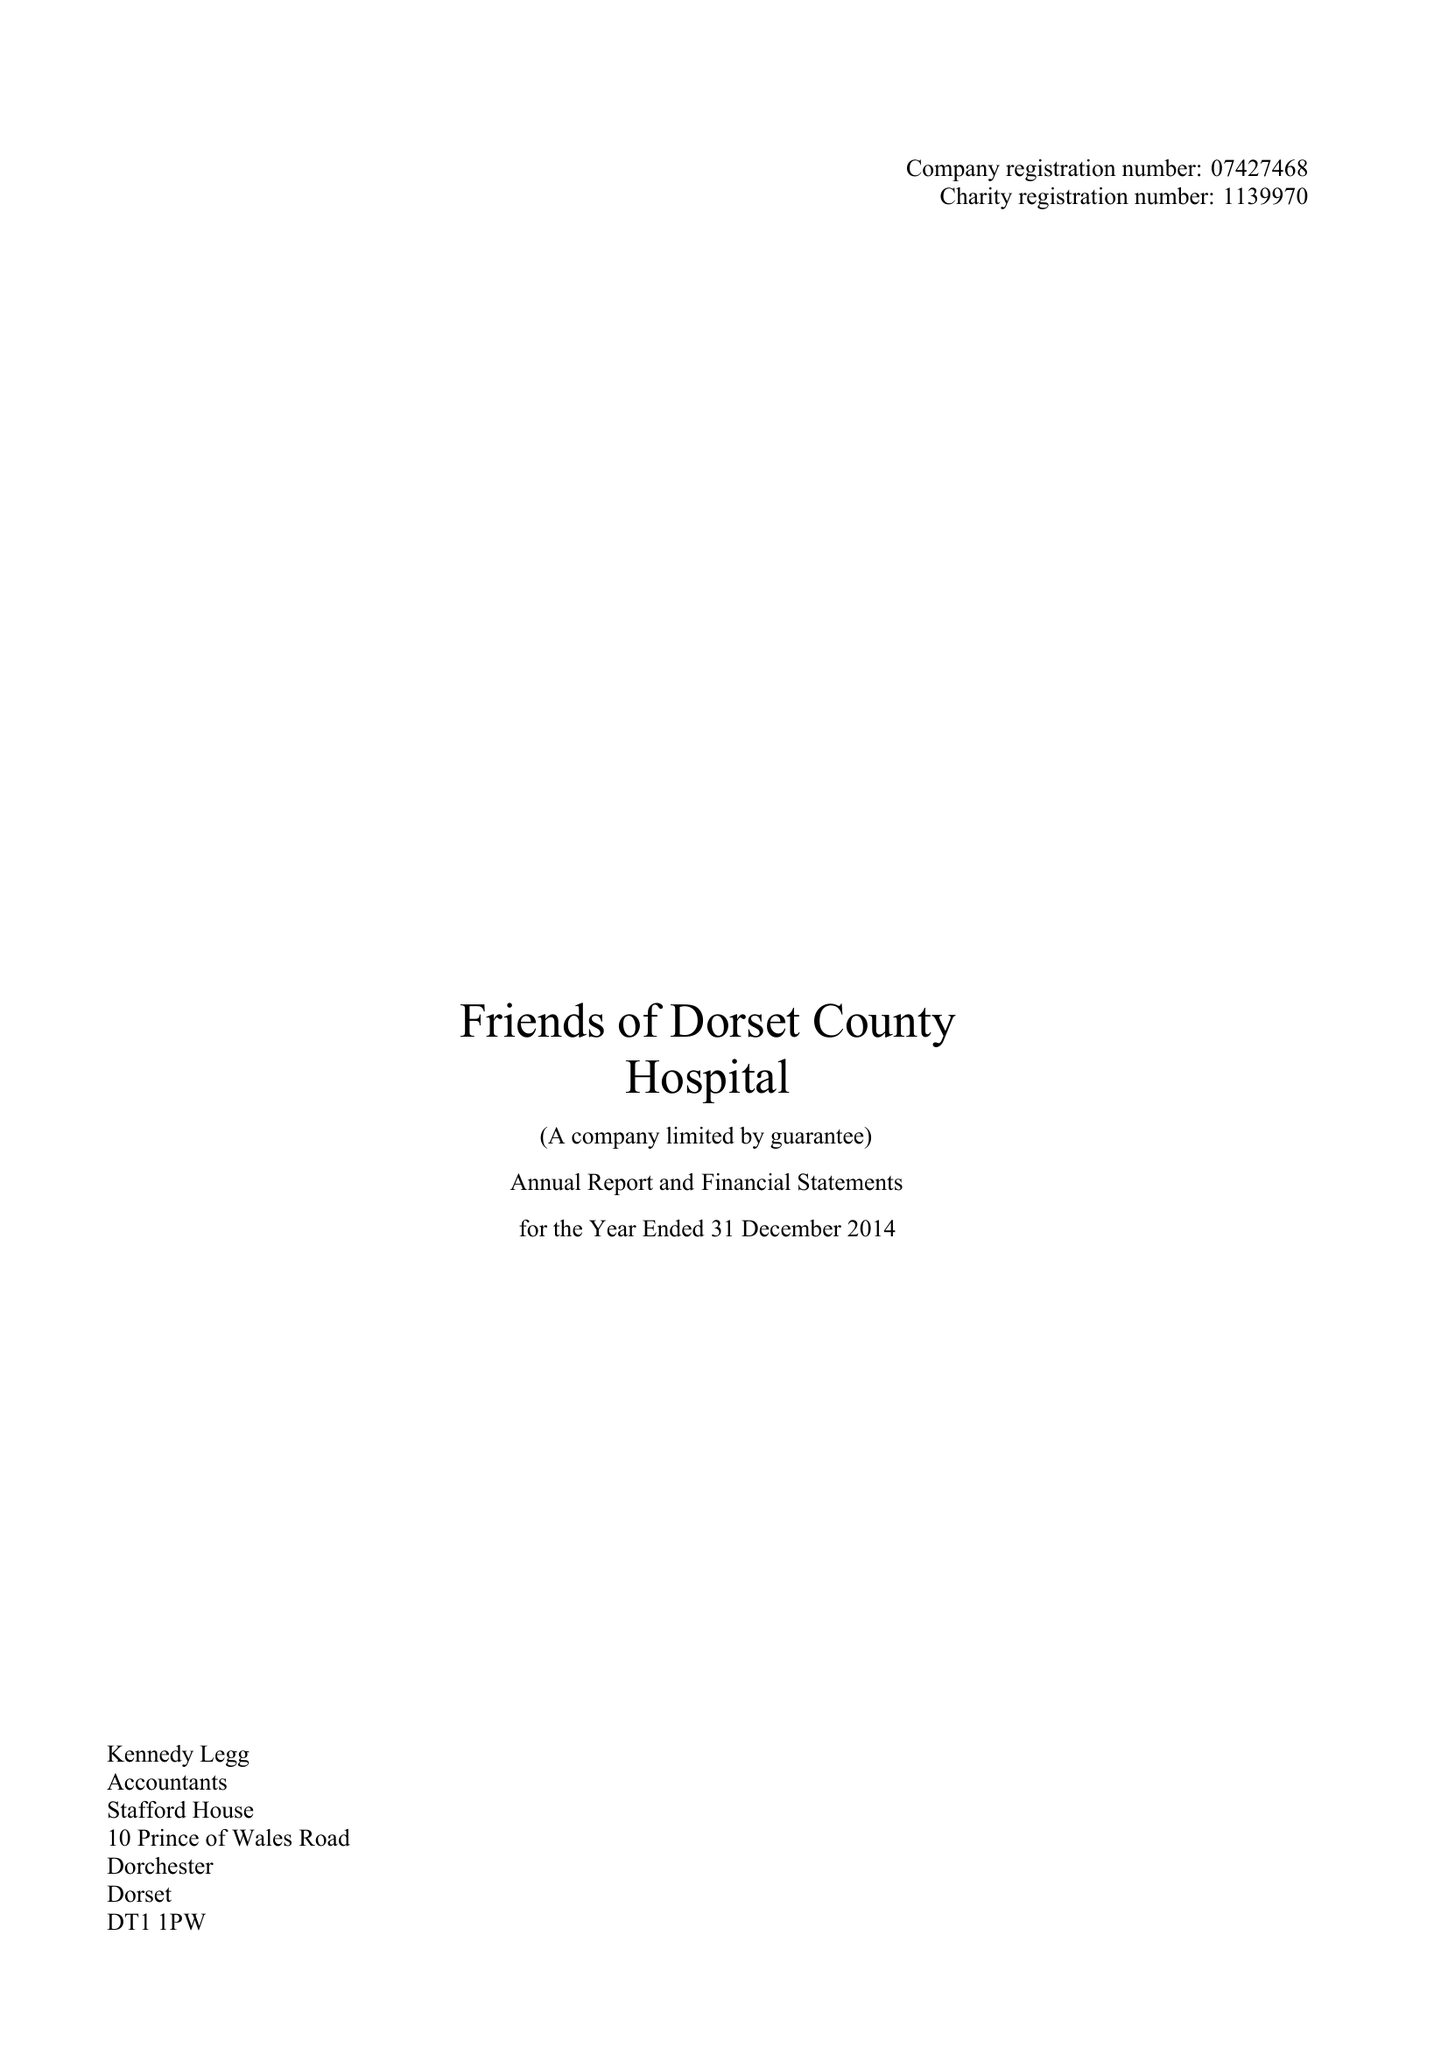What is the value for the charity_number?
Answer the question using a single word or phrase. 1139970 